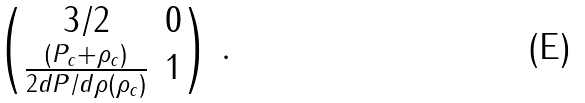<formula> <loc_0><loc_0><loc_500><loc_500>\begin{pmatrix} 3 / 2 & 0 \\ \frac { ( P _ { c } + \rho _ { c } ) } { 2 d P / d \rho ( \rho _ { c } ) } & 1 \end{pmatrix} \, .</formula> 